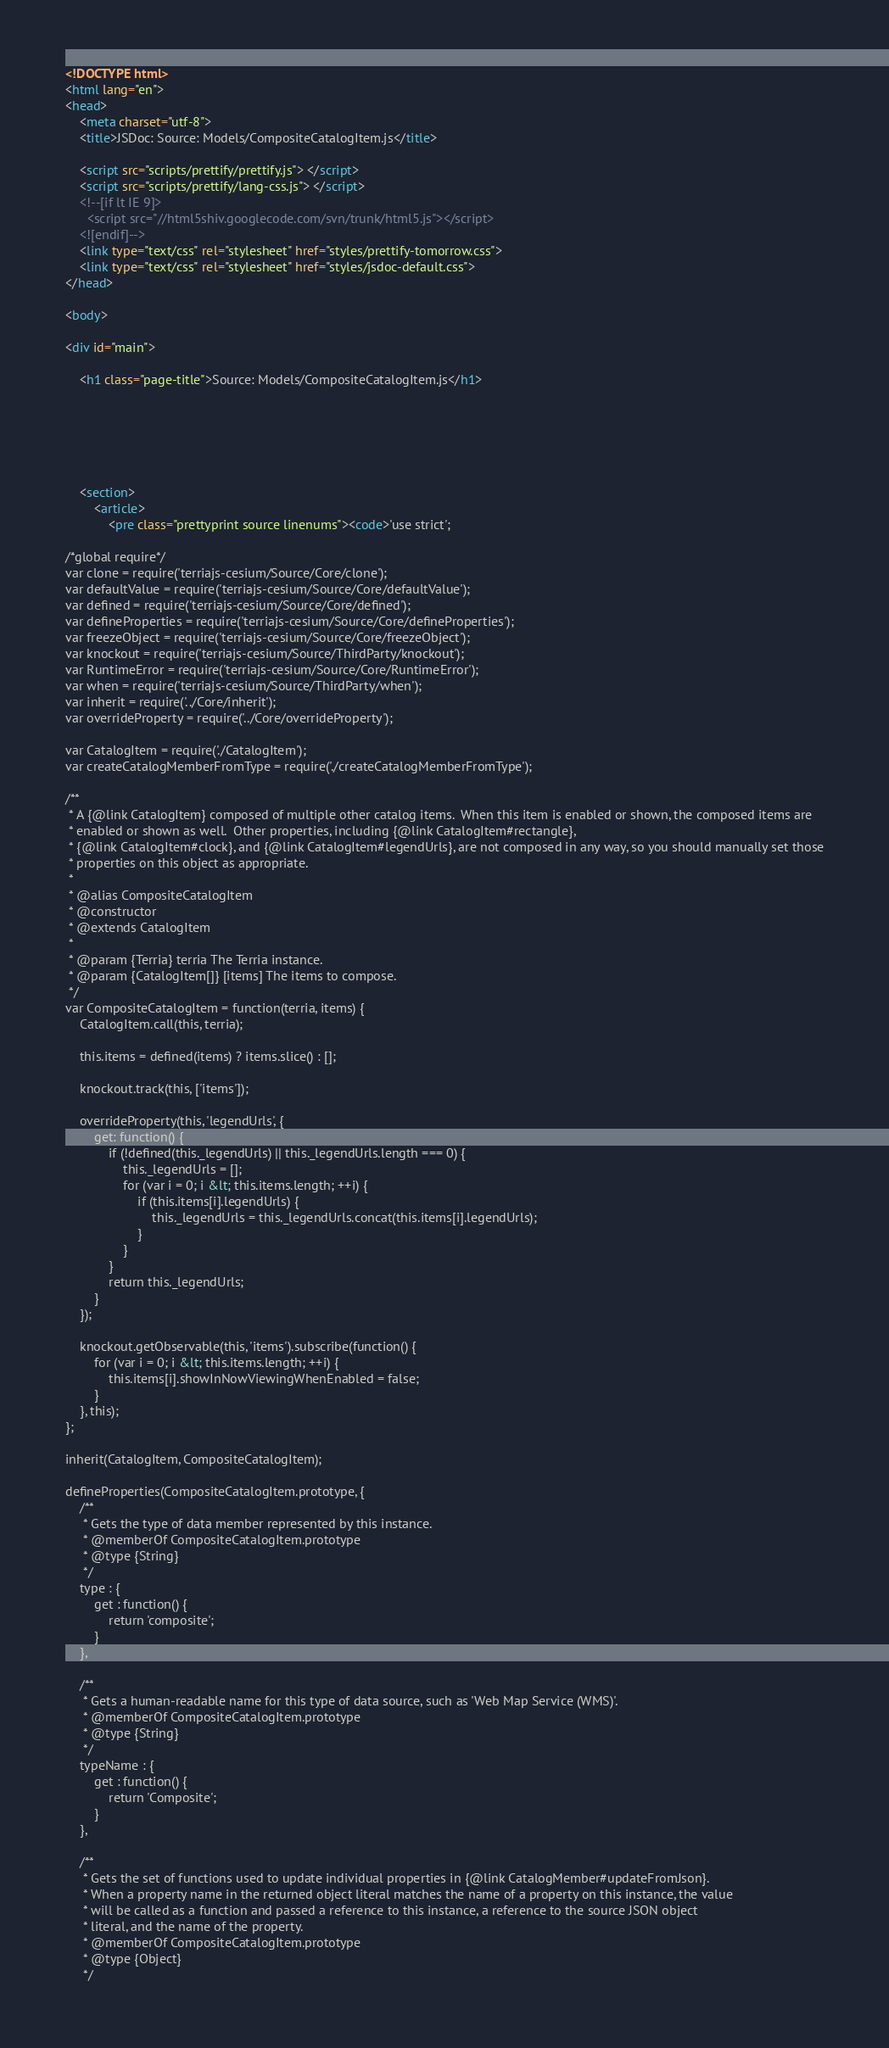<code> <loc_0><loc_0><loc_500><loc_500><_HTML_><!DOCTYPE html>
<html lang="en">
<head>
    <meta charset="utf-8">
    <title>JSDoc: Source: Models/CompositeCatalogItem.js</title>

    <script src="scripts/prettify/prettify.js"> </script>
    <script src="scripts/prettify/lang-css.js"> </script>
    <!--[if lt IE 9]>
      <script src="//html5shiv.googlecode.com/svn/trunk/html5.js"></script>
    <![endif]-->
    <link type="text/css" rel="stylesheet" href="styles/prettify-tomorrow.css">
    <link type="text/css" rel="stylesheet" href="styles/jsdoc-default.css">
</head>

<body>

<div id="main">

    <h1 class="page-title">Source: Models/CompositeCatalogItem.js</h1>

    



    
    <section>
        <article>
            <pre class="prettyprint source linenums"><code>'use strict';

/*global require*/
var clone = require('terriajs-cesium/Source/Core/clone');
var defaultValue = require('terriajs-cesium/Source/Core/defaultValue');
var defined = require('terriajs-cesium/Source/Core/defined');
var defineProperties = require('terriajs-cesium/Source/Core/defineProperties');
var freezeObject = require('terriajs-cesium/Source/Core/freezeObject');
var knockout = require('terriajs-cesium/Source/ThirdParty/knockout');
var RuntimeError = require('terriajs-cesium/Source/Core/RuntimeError');
var when = require('terriajs-cesium/Source/ThirdParty/when');
var inherit = require('../Core/inherit');
var overrideProperty = require('../Core/overrideProperty');

var CatalogItem = require('./CatalogItem');
var createCatalogMemberFromType = require('./createCatalogMemberFromType');

/**
 * A {@link CatalogItem} composed of multiple other catalog items.  When this item is enabled or shown, the composed items are
 * enabled or shown as well.  Other properties, including {@link CatalogItem#rectangle},
 * {@link CatalogItem#clock}, and {@link CatalogItem#legendUrls}, are not composed in any way, so you should manually set those
 * properties on this object as appropriate.
 *
 * @alias CompositeCatalogItem
 * @constructor
 * @extends CatalogItem
 *
 * @param {Terria} terria The Terria instance.
 * @param {CatalogItem[]} [items] The items to compose.
 */
var CompositeCatalogItem = function(terria, items) {
	CatalogItem.call(this, terria);

	this.items = defined(items) ? items.slice() : [];

    knockout.track(this, ['items']);

    overrideProperty(this, 'legendUrls', {
        get: function() {
            if (!defined(this._legendUrls) || this._legendUrls.length === 0) {
                this._legendUrls = [];
                for (var i = 0; i &lt; this.items.length; ++i) {
                    if (this.items[i].legendUrls) {
                        this._legendUrls = this._legendUrls.concat(this.items[i].legendUrls);
                    }
                }
            }
            return this._legendUrls;
        }
    });

	knockout.getObservable(this, 'items').subscribe(function() {
		for (var i = 0; i &lt; this.items.length; ++i) {
			this.items[i].showInNowViewingWhenEnabled = false;
		}
	}, this);
};

inherit(CatalogItem, CompositeCatalogItem);

defineProperties(CompositeCatalogItem.prototype, {
    /**
     * Gets the type of data member represented by this instance.
     * @memberOf CompositeCatalogItem.prototype
     * @type {String}
     */
    type : {
        get : function() {
            return 'composite';
        }
    },

    /**
     * Gets a human-readable name for this type of data source, such as 'Web Map Service (WMS)'.
     * @memberOf CompositeCatalogItem.prototype
     * @type {String}
     */
    typeName : {
        get : function() {
            return 'Composite';
        }
    },

    /**
     * Gets the set of functions used to update individual properties in {@link CatalogMember#updateFromJson}.
     * When a property name in the returned object literal matches the name of a property on this instance, the value
     * will be called as a function and passed a reference to this instance, a reference to the source JSON object
     * literal, and the name of the property.
     * @memberOf CompositeCatalogItem.prototype
     * @type {Object}
     */</code> 